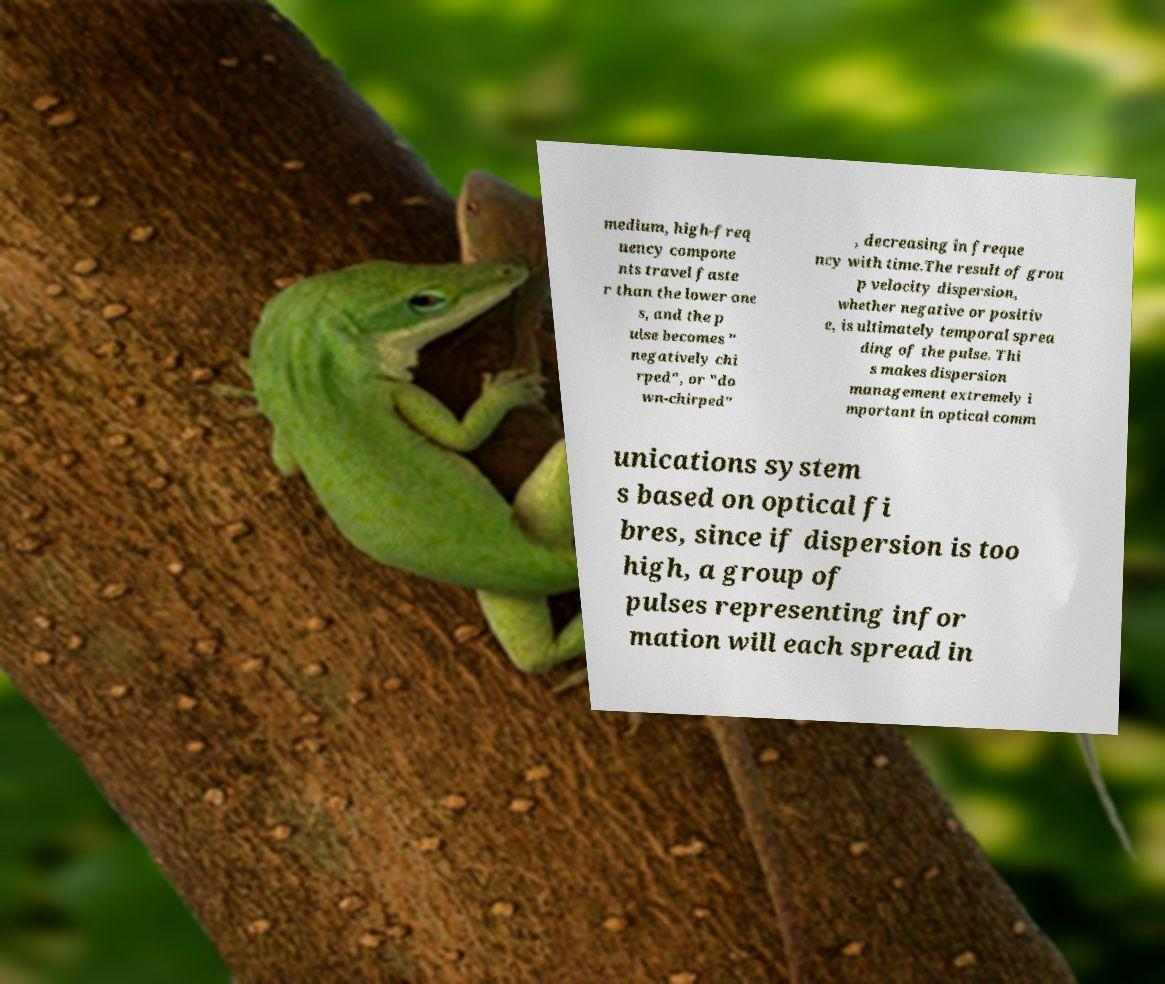Can you read and provide the text displayed in the image?This photo seems to have some interesting text. Can you extract and type it out for me? medium, high-freq uency compone nts travel faste r than the lower one s, and the p ulse becomes " negatively chi rped", or "do wn-chirped" , decreasing in freque ncy with time.The result of grou p velocity dispersion, whether negative or positiv e, is ultimately temporal sprea ding of the pulse. Thi s makes dispersion management extremely i mportant in optical comm unications system s based on optical fi bres, since if dispersion is too high, a group of pulses representing infor mation will each spread in 